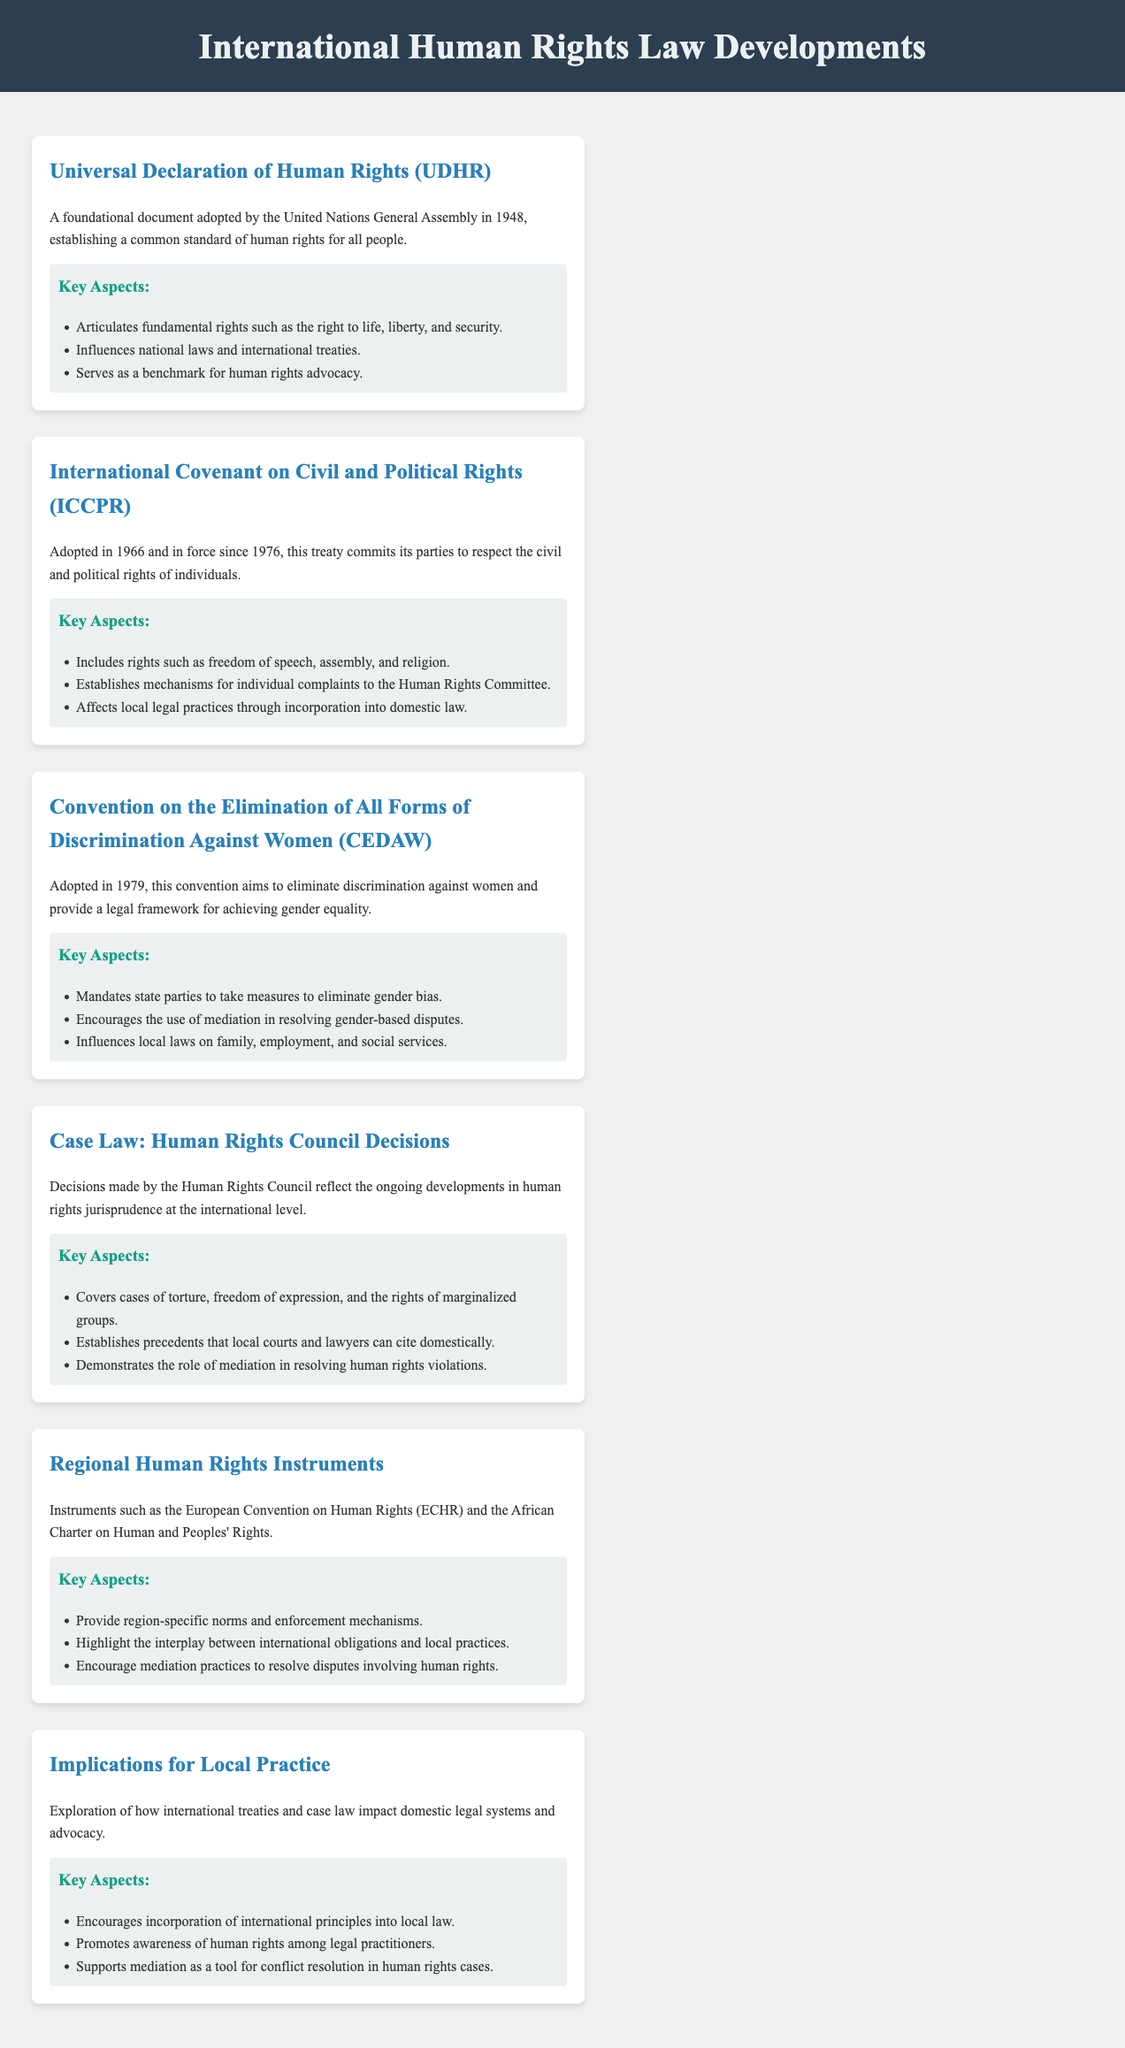What is the year of adoption for the UDHR? The year of adoption for the UDHR is mentioned as 1948 in the document.
Answer: 1948 Which treaty is focused on civil and political rights? The document specifies the International Covenant on Civil and Political Rights (ICCPR) as the treaty focused on civil and political rights.
Answer: ICCPR What key aspect does CEDAW mandate state parties to eliminate? The key aspect mentioned is the elimination of gender bias.
Answer: Gender bias What type of cases do Human Rights Council decisions cover? The document lists types of cases covered, including torture, freedom of expression, and rights of marginalized groups.
Answer: Torture, freedom of expression, rights of marginalized groups What do regional human rights instruments provide? The document states that regional human rights instruments provide region-specific norms and enforcement mechanisms.
Answer: Region-specific norms and enforcement mechanisms What is a recommended tool for conflict resolution in human rights cases? The document highlights mediation as a recommended tool for conflict resolution in human rights cases.
Answer: Mediation In what year did the ICCPR come into force? The text indicates that the ICCPR came into force in 1976.
Answer: 1976 What does the document suggest about the incorporation of international principles into local law? It suggests that there is encouragement for the incorporation of international principles into local law.
Answer: Encouragement What does the document imply about awareness of human rights among legal practitioners? It implies that there is a promotion of awareness of human rights among legal practitioners.
Answer: Promotion of awareness 